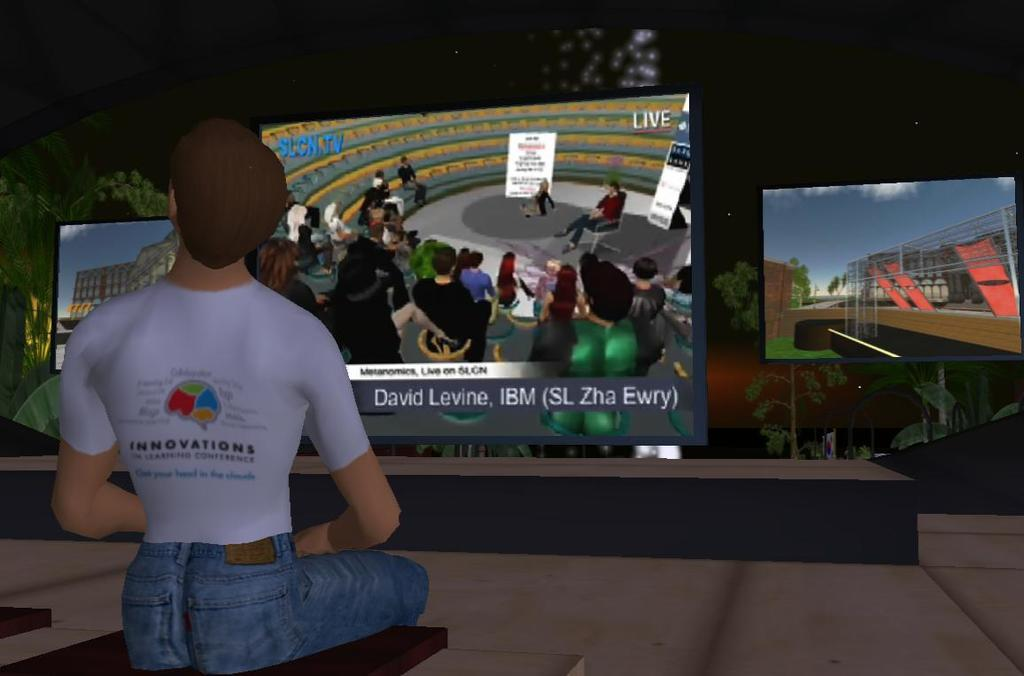What is the man in the image doing? The man is sitting on a bench in the image. What type of image is it? The image is animated. What can be seen in the background of the image? There are screens in the background of the image. What is displayed on the screens? Pictures and text are visible on the screens. What type of quill is the man using to write on the screens in the image? There is no quill present in the image, and the man is not writing on the screens. 